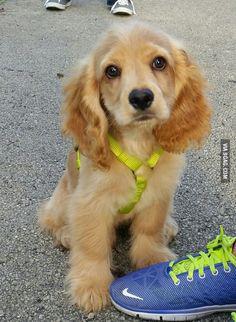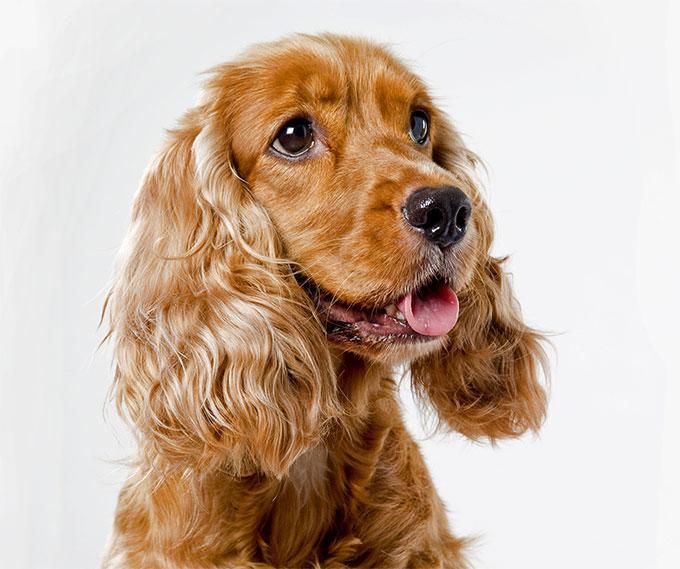The first image is the image on the left, the second image is the image on the right. Given the left and right images, does the statement "One image shows a blonde spaniel with a metal tag on its collar and its head cocked to the left." hold true? Answer yes or no. No. The first image is the image on the left, the second image is the image on the right. Analyze the images presented: Is the assertion "The dog in the image on the left is outside." valid? Answer yes or no. Yes. 